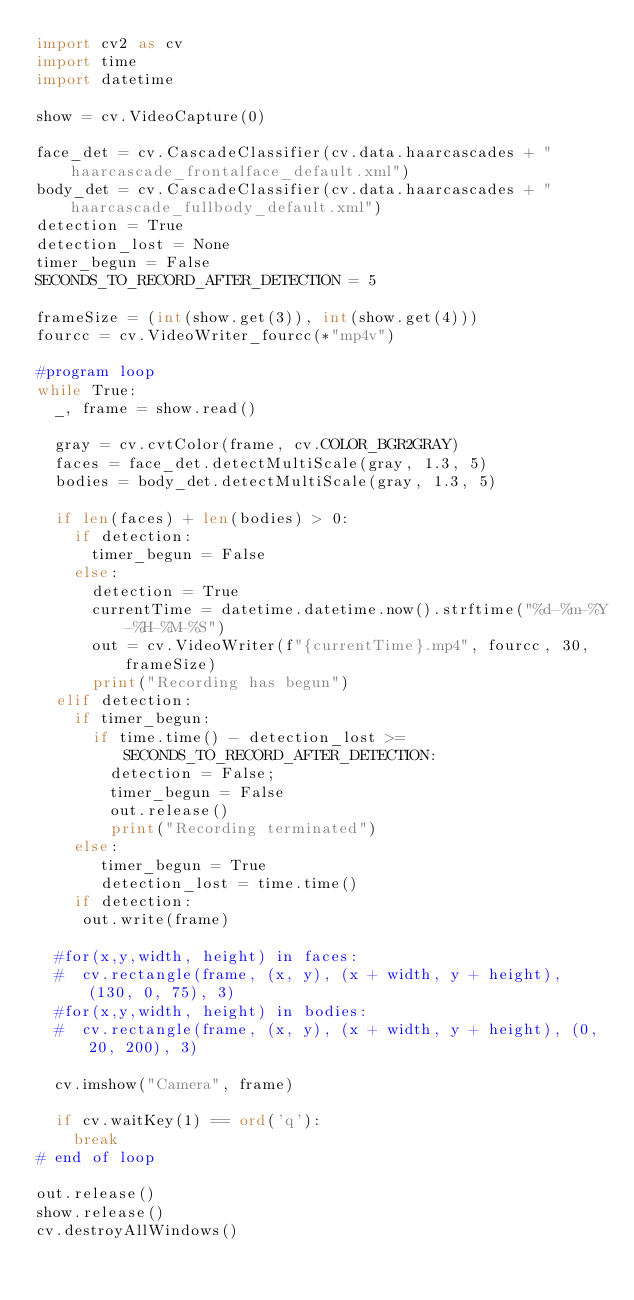<code> <loc_0><loc_0><loc_500><loc_500><_Python_>import cv2 as cv
import time
import datetime

show = cv.VideoCapture(0)

face_det = cv.CascadeClassifier(cv.data.haarcascades + "haarcascade_frontalface_default.xml")
body_det = cv.CascadeClassifier(cv.data.haarcascades + "haarcascade_fullbody_default.xml")
detection = True
detection_lost = None
timer_begun = False
SECONDS_TO_RECORD_AFTER_DETECTION = 5

frameSize = (int(show.get(3)), int(show.get(4)))
fourcc = cv.VideoWriter_fourcc(*"mp4v")

#program loop
while True:
  _, frame = show.read()
  
  gray = cv.cvtColor(frame, cv.COLOR_BGR2GRAY)
  faces = face_det.detectMultiScale(gray, 1.3, 5)
  bodies = body_det.detectMultiScale(gray, 1.3, 5)
  
  if len(faces) + len(bodies) > 0:
    if detection:
      timer_begun = False
    else:
      detection = True
      currentTime = datetime.datetime.now().strftime("%d-%m-%Y-%H-%M-%S")
      out = cv.VideoWriter(f"{currentTime}.mp4", fourcc, 30, frameSize)
      print("Recording has begun")
  elif detection:
    if timer_begun:
      if time.time() - detection_lost >= SECONDS_TO_RECORD_AFTER_DETECTION:
        detection = False;
        timer_begun = False
        out.release()
        print("Recording terminated")
    else:
       timer_begun = True
       detection_lost = time.time()
    if detection:
     out.write(frame)
  
  #for(x,y,width, height) in faces:
  #  cv.rectangle(frame, (x, y), (x + width, y + height), (130, 0, 75), 3)
  #for(x,y,width, height) in bodies:
  #  cv.rectangle(frame, (x, y), (x + width, y + height), (0, 20, 200), 3)
  
  cv.imshow("Camera", frame)
  
  if cv.waitKey(1) == ord('q'):
    break
# end of loop

out.release()
show.release()
cv.destroyAllWindows()</code> 